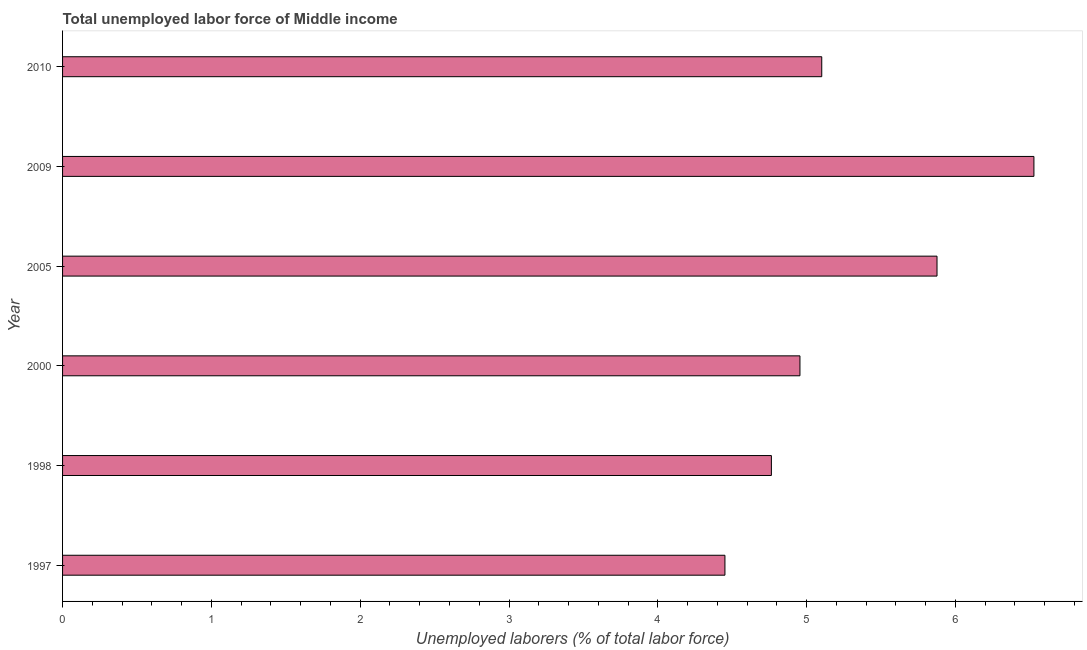Does the graph contain grids?
Provide a succinct answer. No. What is the title of the graph?
Provide a short and direct response. Total unemployed labor force of Middle income. What is the label or title of the X-axis?
Give a very brief answer. Unemployed laborers (% of total labor force). What is the label or title of the Y-axis?
Ensure brevity in your answer.  Year. What is the total unemployed labour force in 2009?
Your response must be concise. 6.53. Across all years, what is the maximum total unemployed labour force?
Make the answer very short. 6.53. Across all years, what is the minimum total unemployed labour force?
Keep it short and to the point. 4.45. In which year was the total unemployed labour force maximum?
Offer a very short reply. 2009. What is the sum of the total unemployed labour force?
Offer a terse response. 31.67. What is the difference between the total unemployed labour force in 1997 and 2009?
Keep it short and to the point. -2.08. What is the average total unemployed labour force per year?
Your response must be concise. 5.28. What is the median total unemployed labour force?
Keep it short and to the point. 5.03. Do a majority of the years between 2009 and 2005 (inclusive) have total unemployed labour force greater than 3 %?
Your response must be concise. No. What is the ratio of the total unemployed labour force in 1997 to that in 1998?
Provide a succinct answer. 0.93. Is the difference between the total unemployed labour force in 1997 and 2000 greater than the difference between any two years?
Your response must be concise. No. What is the difference between the highest and the second highest total unemployed labour force?
Offer a very short reply. 0.65. Is the sum of the total unemployed labour force in 1998 and 2005 greater than the maximum total unemployed labour force across all years?
Keep it short and to the point. Yes. What is the difference between the highest and the lowest total unemployed labour force?
Provide a succinct answer. 2.08. In how many years, is the total unemployed labour force greater than the average total unemployed labour force taken over all years?
Your answer should be compact. 2. How many bars are there?
Your response must be concise. 6. What is the difference between two consecutive major ticks on the X-axis?
Give a very brief answer. 1. What is the Unemployed laborers (% of total labor force) in 1997?
Provide a succinct answer. 4.45. What is the Unemployed laborers (% of total labor force) of 1998?
Offer a terse response. 4.76. What is the Unemployed laborers (% of total labor force) of 2000?
Make the answer very short. 4.96. What is the Unemployed laborers (% of total labor force) in 2005?
Offer a terse response. 5.88. What is the Unemployed laborers (% of total labor force) of 2009?
Make the answer very short. 6.53. What is the Unemployed laborers (% of total labor force) in 2010?
Provide a short and direct response. 5.1. What is the difference between the Unemployed laborers (% of total labor force) in 1997 and 1998?
Your answer should be compact. -0.31. What is the difference between the Unemployed laborers (% of total labor force) in 1997 and 2000?
Your answer should be very brief. -0.5. What is the difference between the Unemployed laborers (% of total labor force) in 1997 and 2005?
Your answer should be very brief. -1.43. What is the difference between the Unemployed laborers (% of total labor force) in 1997 and 2009?
Provide a succinct answer. -2.08. What is the difference between the Unemployed laborers (% of total labor force) in 1997 and 2010?
Your answer should be very brief. -0.65. What is the difference between the Unemployed laborers (% of total labor force) in 1998 and 2000?
Offer a terse response. -0.19. What is the difference between the Unemployed laborers (% of total labor force) in 1998 and 2005?
Offer a very short reply. -1.11. What is the difference between the Unemployed laborers (% of total labor force) in 1998 and 2009?
Provide a short and direct response. -1.76. What is the difference between the Unemployed laborers (% of total labor force) in 1998 and 2010?
Your answer should be compact. -0.34. What is the difference between the Unemployed laborers (% of total labor force) in 2000 and 2005?
Your response must be concise. -0.92. What is the difference between the Unemployed laborers (% of total labor force) in 2000 and 2009?
Provide a succinct answer. -1.57. What is the difference between the Unemployed laborers (% of total labor force) in 2000 and 2010?
Provide a succinct answer. -0.15. What is the difference between the Unemployed laborers (% of total labor force) in 2005 and 2009?
Your response must be concise. -0.65. What is the difference between the Unemployed laborers (% of total labor force) in 2005 and 2010?
Keep it short and to the point. 0.77. What is the difference between the Unemployed laborers (% of total labor force) in 2009 and 2010?
Offer a terse response. 1.43. What is the ratio of the Unemployed laborers (% of total labor force) in 1997 to that in 1998?
Make the answer very short. 0.93. What is the ratio of the Unemployed laborers (% of total labor force) in 1997 to that in 2000?
Offer a very short reply. 0.9. What is the ratio of the Unemployed laborers (% of total labor force) in 1997 to that in 2005?
Offer a very short reply. 0.76. What is the ratio of the Unemployed laborers (% of total labor force) in 1997 to that in 2009?
Offer a terse response. 0.68. What is the ratio of the Unemployed laborers (% of total labor force) in 1997 to that in 2010?
Keep it short and to the point. 0.87. What is the ratio of the Unemployed laborers (% of total labor force) in 1998 to that in 2000?
Your answer should be very brief. 0.96. What is the ratio of the Unemployed laborers (% of total labor force) in 1998 to that in 2005?
Offer a very short reply. 0.81. What is the ratio of the Unemployed laborers (% of total labor force) in 1998 to that in 2009?
Your answer should be compact. 0.73. What is the ratio of the Unemployed laborers (% of total labor force) in 1998 to that in 2010?
Give a very brief answer. 0.93. What is the ratio of the Unemployed laborers (% of total labor force) in 2000 to that in 2005?
Provide a short and direct response. 0.84. What is the ratio of the Unemployed laborers (% of total labor force) in 2000 to that in 2009?
Provide a succinct answer. 0.76. What is the ratio of the Unemployed laborers (% of total labor force) in 2005 to that in 2010?
Your answer should be compact. 1.15. What is the ratio of the Unemployed laborers (% of total labor force) in 2009 to that in 2010?
Offer a very short reply. 1.28. 